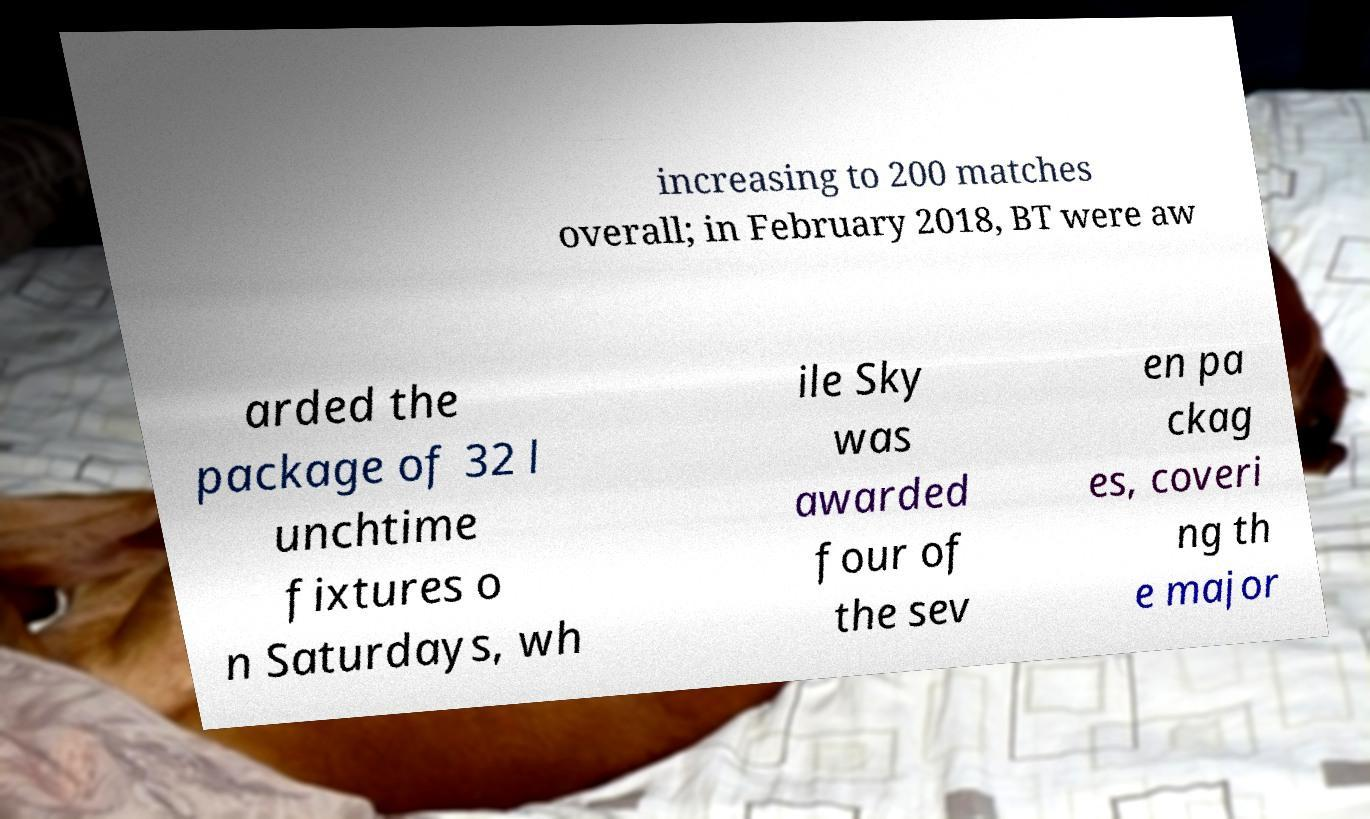For documentation purposes, I need the text within this image transcribed. Could you provide that? increasing to 200 matches overall; in February 2018, BT were aw arded the package of 32 l unchtime fixtures o n Saturdays, wh ile Sky was awarded four of the sev en pa ckag es, coveri ng th e major 